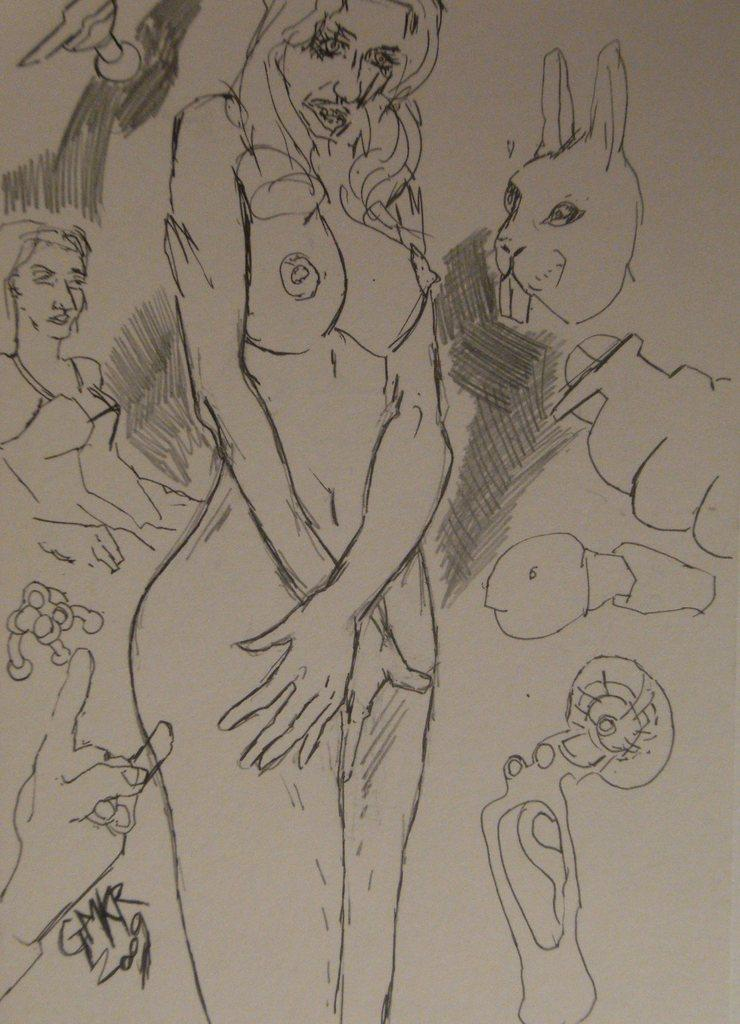What is the main subject of the drawing in the image? There is a drawing of a nude woman in the middle of the image. What other figures are present in the drawing? There are drawings of persons and animals beside the nude woman. What is the color of the background in the image? The background of the image is white in color. What page number is the drawing on in the image? The image does not depict a book or a page number; it is a drawing on a white background. Is there a birthday celebration happening in the image? There is no indication of a birthday celebration in the image; it is a drawing of a nude woman and other figures. 